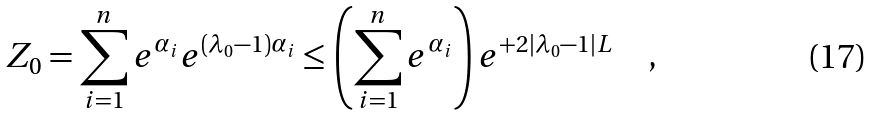Convert formula to latex. <formula><loc_0><loc_0><loc_500><loc_500>Z _ { 0 } = \sum _ { i = 1 } ^ { n } e ^ { \alpha _ { i } } e ^ { ( \lambda _ { 0 } - 1 ) \alpha _ { i } } \leq \left ( \sum _ { i = 1 } ^ { n } e ^ { \alpha _ { i } } \right ) e ^ { + 2 | \lambda _ { 0 } - 1 | L } \quad ,</formula> 